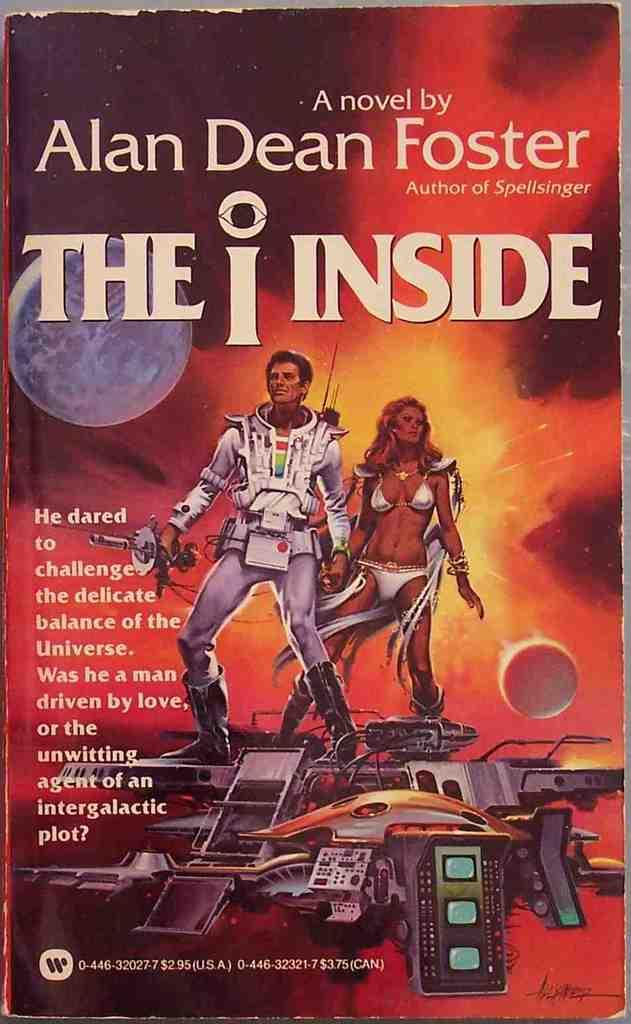<image>
Present a compact description of the photo's key features. Book cover for The Inside showing a man and a woman on top of a spaceship. 